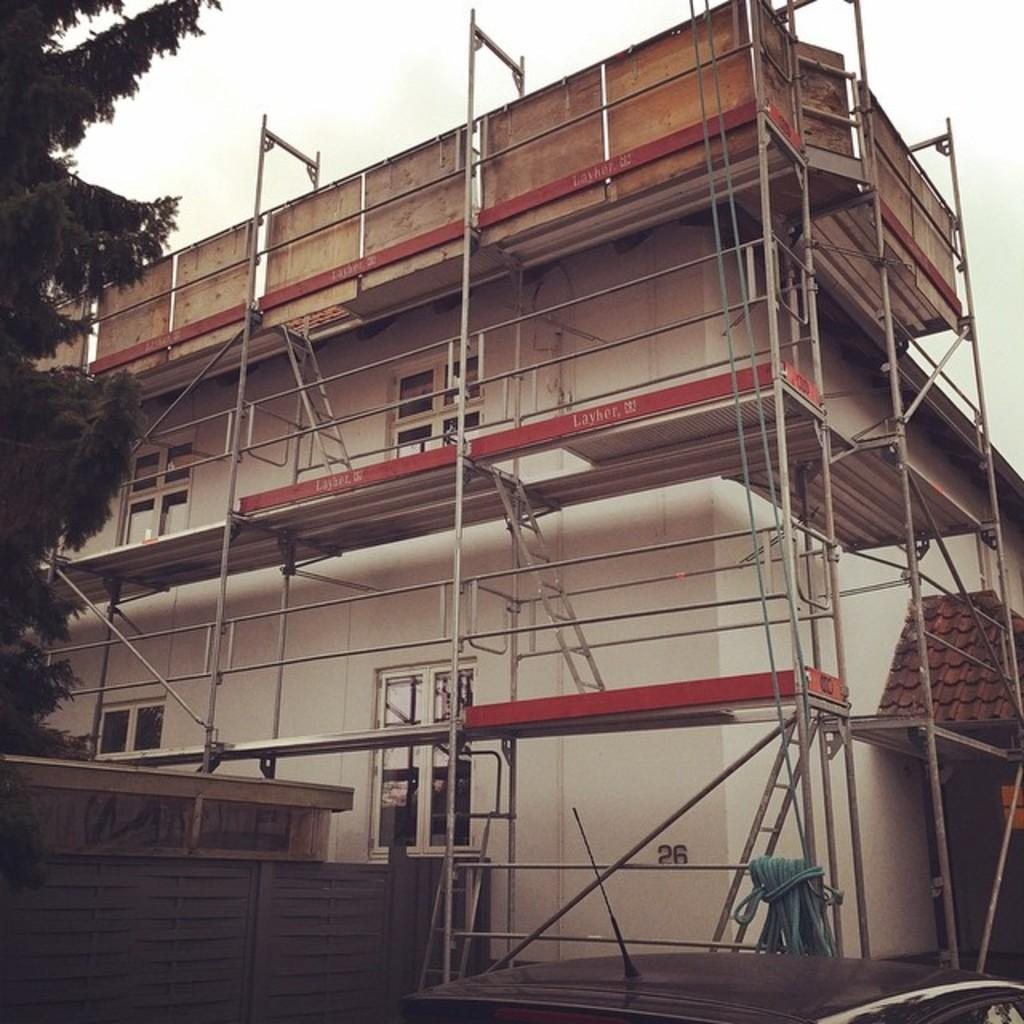What is the main structure in the image? There is a building in the image. Where is the tree located in the image? The tree is on the left side of the image. What can be seen in the background of the image? The sky is visible in the background of the image. What type of chalk is being used to draw on the building in the image? There is no chalk or drawing present on the building in the image. 